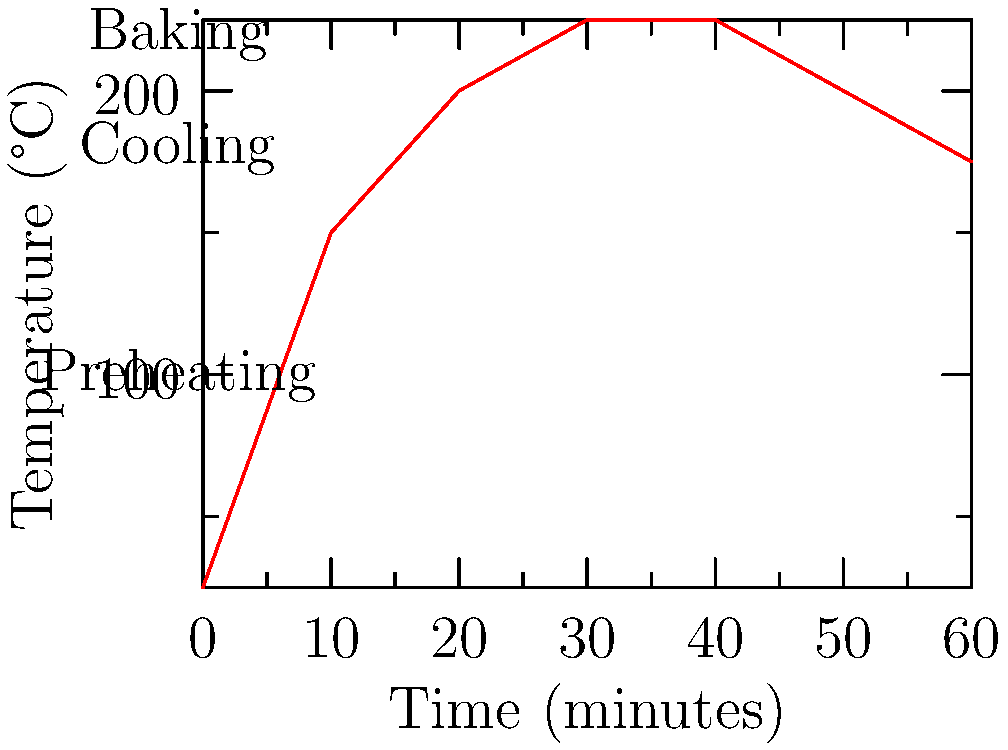According to the temperature curve for traditional bread baking, at which point does the oven temperature reach its maximum, and how long should this peak temperature be maintained? To determine the optimal temperature curve for baking bread, we need to analyze the graph carefully:

1. The graph shows the temperature (y-axis) over time (x-axis) for a traditional bread baking process.
2. The curve starts at room temperature (25°C) and rapidly increases during the preheating phase.
3. The temperature reaches its maximum at 225°C.
4. This peak temperature is maintained for a period of time, forming a plateau on the graph.
5. By examining the x-axis, we can see that the plateau starts at 30 minutes and ends at 40 minutes.
6. Therefore, the peak temperature of 225°C is maintained for 10 minutes (from 30 to 40 minutes into the baking process).
7. After this period, the temperature begins to decrease gradually for the cooling phase.

This 10-minute period at peak temperature is crucial for proper crust formation and even baking of the bread's interior, adhering to traditional baking methods.
Answer: 225°C for 10 minutes 